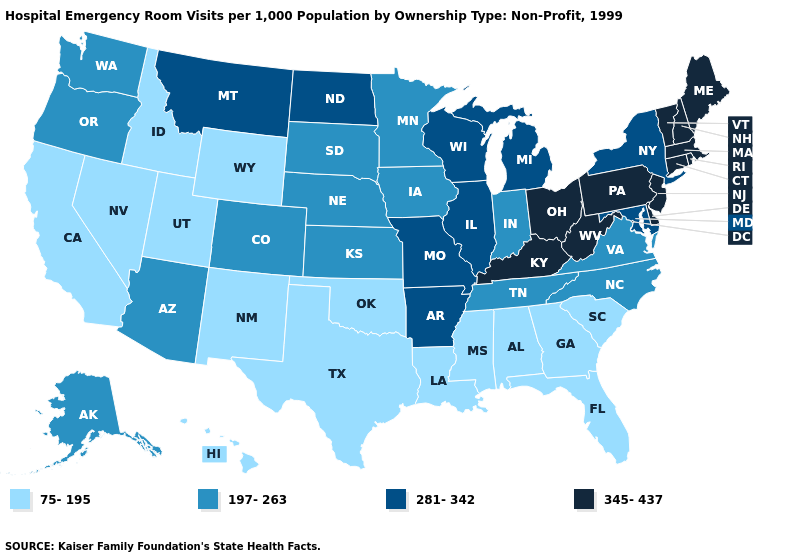Does Alabama have the highest value in the South?
Write a very short answer. No. Does New York have the highest value in the Northeast?
Answer briefly. No. Does Kentucky have the same value as Colorado?
Quick response, please. No. What is the value of South Dakota?
Be succinct. 197-263. What is the value of Minnesota?
Write a very short answer. 197-263. Does New Hampshire have the highest value in the USA?
Be succinct. Yes. What is the lowest value in states that border Nevada?
Keep it brief. 75-195. How many symbols are there in the legend?
Quick response, please. 4. How many symbols are there in the legend?
Quick response, please. 4. Which states have the lowest value in the USA?
Answer briefly. Alabama, California, Florida, Georgia, Hawaii, Idaho, Louisiana, Mississippi, Nevada, New Mexico, Oklahoma, South Carolina, Texas, Utah, Wyoming. What is the lowest value in the Northeast?
Concise answer only. 281-342. What is the value of Colorado?
Quick response, please. 197-263. What is the highest value in the USA?
Concise answer only. 345-437. Which states hav the highest value in the Northeast?
Short answer required. Connecticut, Maine, Massachusetts, New Hampshire, New Jersey, Pennsylvania, Rhode Island, Vermont. Name the states that have a value in the range 345-437?
Short answer required. Connecticut, Delaware, Kentucky, Maine, Massachusetts, New Hampshire, New Jersey, Ohio, Pennsylvania, Rhode Island, Vermont, West Virginia. 